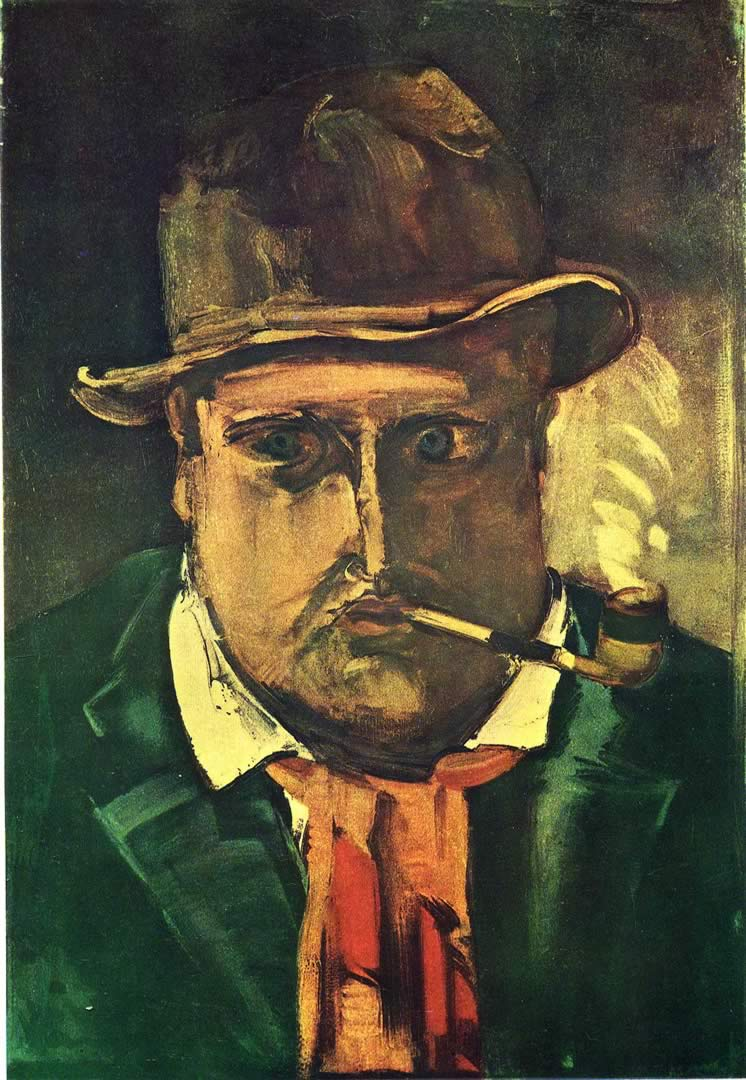Could you explain the significance of the color choices in this painting? Absolutely. The dominant use of dark greens and browns sets a somber, earthy mood, indicative of perhaps the setting or the mental state of the figure. The pops of red in his tie and yellow highlights serve to draw the viewer's eye, creating focal points that break the overall gloom and add a layer of complexity. These colors may symbolize deeper themes such as passion, conflict, or a spark of vitality within the somberness of the man's life. How does this combination of colors contribute to the expressionist style of the artwork? Expressionism often uses vivid, contrasting colors to convey emotional depth and to visually articulate the turmoil depicted. In this painting, the stark contrasts and saturated hues enhance the emotional expressiveness, aligning with expressionist goals to affect the viewer on a psychological level. The deliberate choice of colors not only highlights certain aspects of the figure but also contributes to an overall atmosphere that is charged with emotional intensity. 